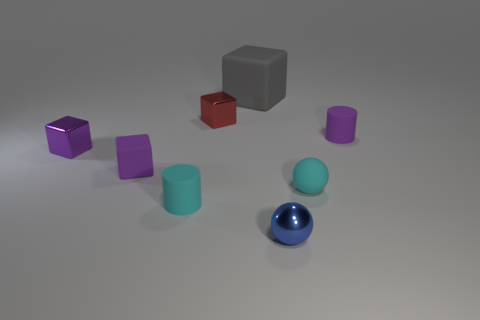Add 2 large cyan matte cylinders. How many objects exist? 10 Subtract all small purple rubber cubes. How many cubes are left? 3 Subtract all red blocks. How many blocks are left? 3 Subtract all spheres. How many objects are left? 6 Subtract 2 spheres. How many spheres are left? 0 Subtract all red cubes. How many cyan cylinders are left? 1 Subtract all blue metallic cubes. Subtract all matte spheres. How many objects are left? 7 Add 7 rubber cylinders. How many rubber cylinders are left? 9 Add 1 purple matte cylinders. How many purple matte cylinders exist? 2 Subtract 0 yellow balls. How many objects are left? 8 